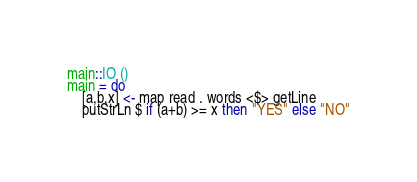Convert code to text. <code><loc_0><loc_0><loc_500><loc_500><_Haskell_>main::IO ()
main = do
    [a,b,x] <- map read . words <$> getLine
    putStrLn $ if (a+b) >= x then "YES" else "NO"</code> 